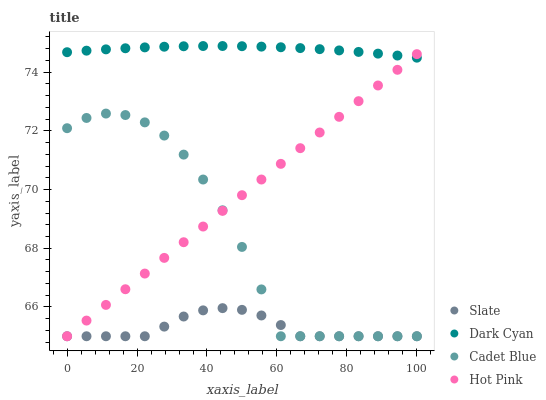Does Slate have the minimum area under the curve?
Answer yes or no. Yes. Does Dark Cyan have the maximum area under the curve?
Answer yes or no. Yes. Does Cadet Blue have the minimum area under the curve?
Answer yes or no. No. Does Cadet Blue have the maximum area under the curve?
Answer yes or no. No. Is Hot Pink the smoothest?
Answer yes or no. Yes. Is Cadet Blue the roughest?
Answer yes or no. Yes. Is Slate the smoothest?
Answer yes or no. No. Is Slate the roughest?
Answer yes or no. No. Does Slate have the lowest value?
Answer yes or no. Yes. Does Dark Cyan have the highest value?
Answer yes or no. Yes. Does Cadet Blue have the highest value?
Answer yes or no. No. Is Cadet Blue less than Dark Cyan?
Answer yes or no. Yes. Is Dark Cyan greater than Slate?
Answer yes or no. Yes. Does Hot Pink intersect Slate?
Answer yes or no. Yes. Is Hot Pink less than Slate?
Answer yes or no. No. Is Hot Pink greater than Slate?
Answer yes or no. No. Does Cadet Blue intersect Dark Cyan?
Answer yes or no. No. 